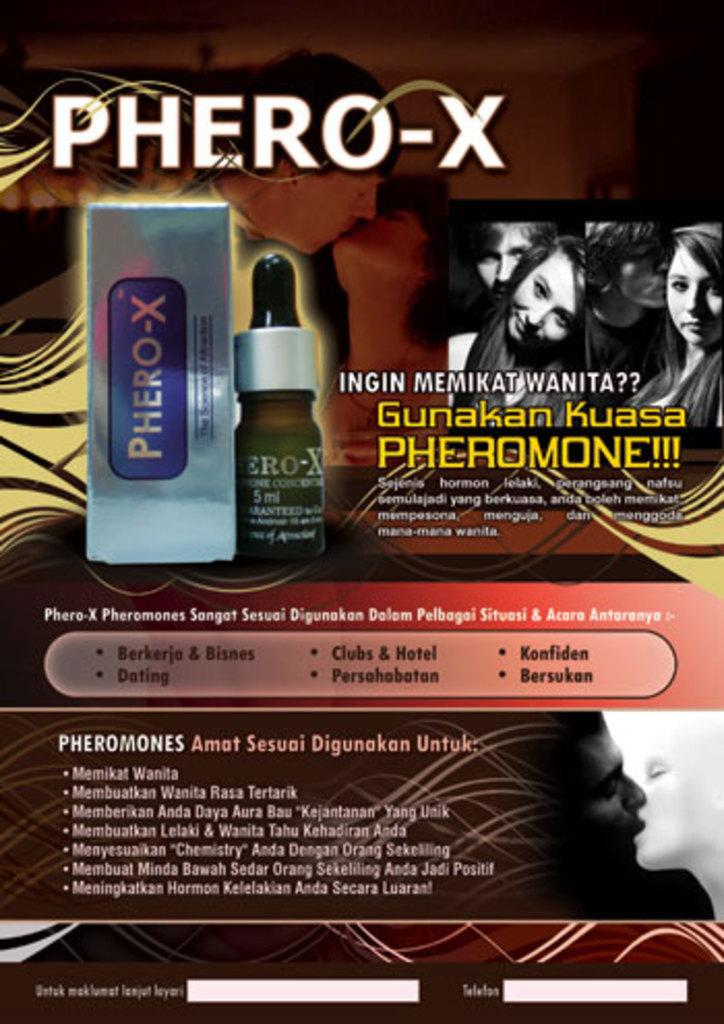What is the main object in the image? There is a poster in the image. What can be seen on the poster? The poster contains images of people and a bottle. Is there any text on the poster? Yes, there is text present on the poster. What type of music can be heard playing in the background of the image? There is no music present in the image; it only contains a poster with images and text. 